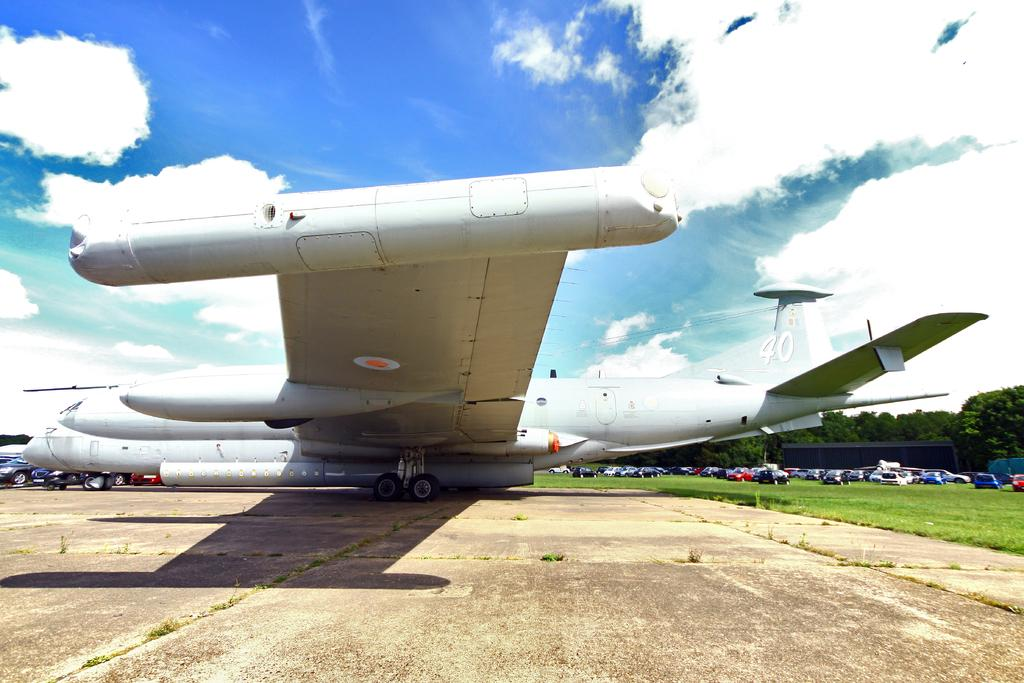What is the main subject in the center of the image? There is an aeroplane in the center of the image. What can be seen in the background of the image? There are cars, trees, and the sky visible in the background of the image. Are there any clouds in the sky? Yes, clouds are present in the sky. What is the name of the toy that the aeroplane is holding in the image? There is no toy present in the image, and the aeroplane is not holding anything. 